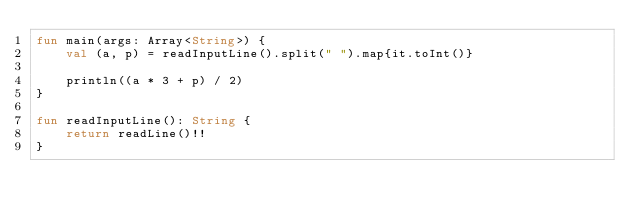<code> <loc_0><loc_0><loc_500><loc_500><_Kotlin_>fun main(args: Array<String>) {
    val (a, p) = readInputLine().split(" ").map{it.toInt()}
    
    println((a * 3 + p) / 2)
}

fun readInputLine(): String {
    return readLine()!!
}
</code> 